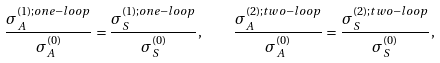Convert formula to latex. <formula><loc_0><loc_0><loc_500><loc_500>\frac { \sigma _ { A } ^ { ( 1 ) ; o n e - l o o p } } { \sigma _ { A } ^ { ( 0 ) } } = \frac { \sigma _ { S } ^ { ( 1 ) ; o n e - l o o p } } { \sigma _ { S } ^ { ( 0 ) } } , \quad \frac { \sigma _ { A } ^ { ( 2 ) ; t w o - l o o p } } { \sigma _ { A } ^ { ( 0 ) } } = \frac { \sigma _ { S } ^ { ( 2 ) ; t w o - l o o p } } { \sigma _ { S } ^ { ( 0 ) } } ,</formula> 